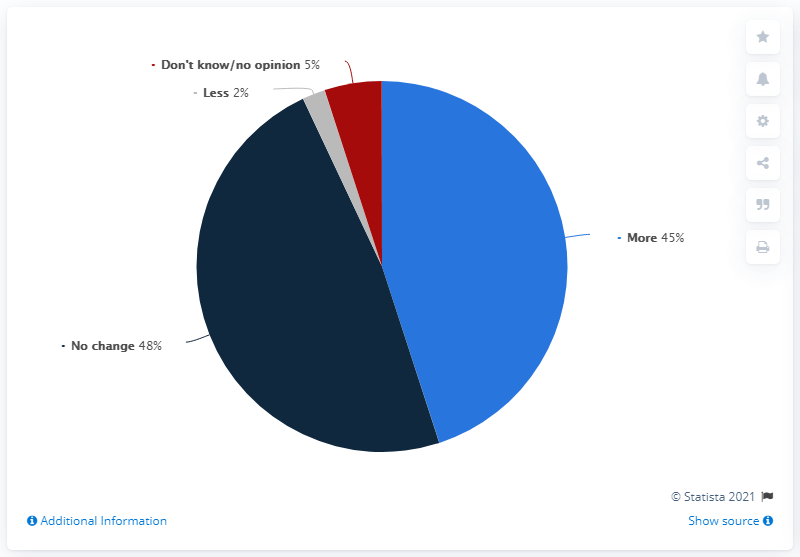Indicate a few pertinent items in this graphic. The pie chart shows four different response types. 